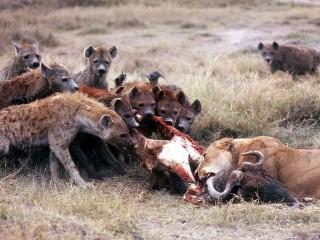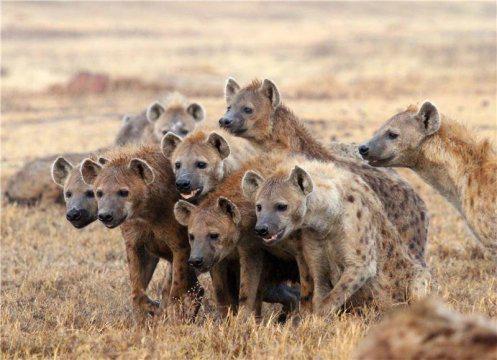The first image is the image on the left, the second image is the image on the right. Assess this claim about the two images: "An image shows no more than two hyenas standing with the carcass of a leopard-type spotted cat.". Correct or not? Answer yes or no. No. The first image is the image on the left, the second image is the image on the right. Evaluate the accuracy of this statement regarding the images: "There's no more than two hyenas in the left image.". Is it true? Answer yes or no. No. 